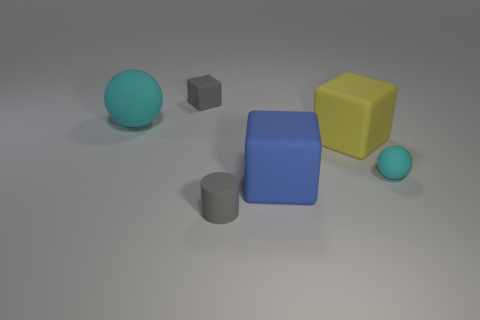Add 2 big blue objects. How many objects exist? 8 Subtract all cylinders. How many objects are left? 5 Add 6 rubber cylinders. How many rubber cylinders are left? 7 Add 2 cyan balls. How many cyan balls exist? 4 Subtract 0 brown blocks. How many objects are left? 6 Subtract all balls. Subtract all blue shiny objects. How many objects are left? 4 